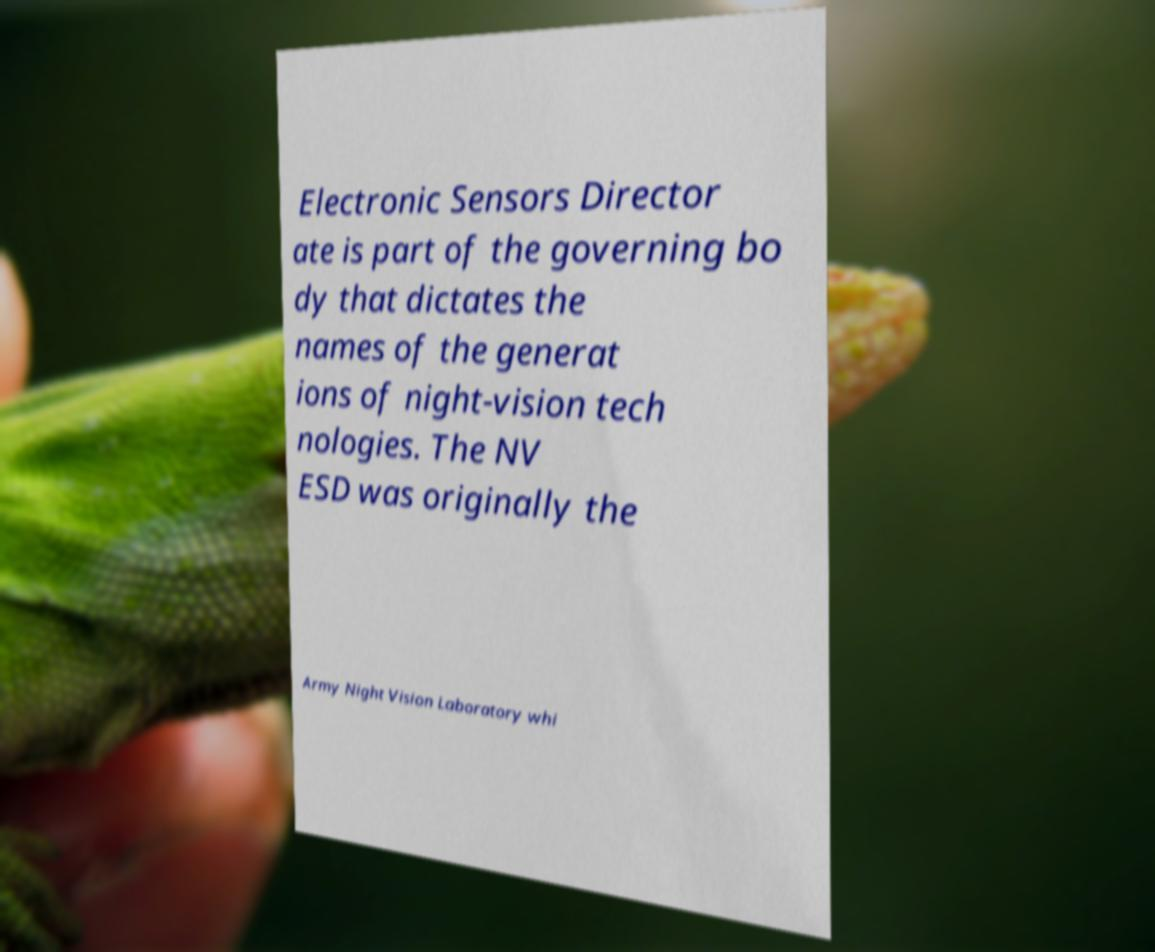I need the written content from this picture converted into text. Can you do that? Electronic Sensors Director ate is part of the governing bo dy that dictates the names of the generat ions of night-vision tech nologies. The NV ESD was originally the Army Night Vision Laboratory whi 